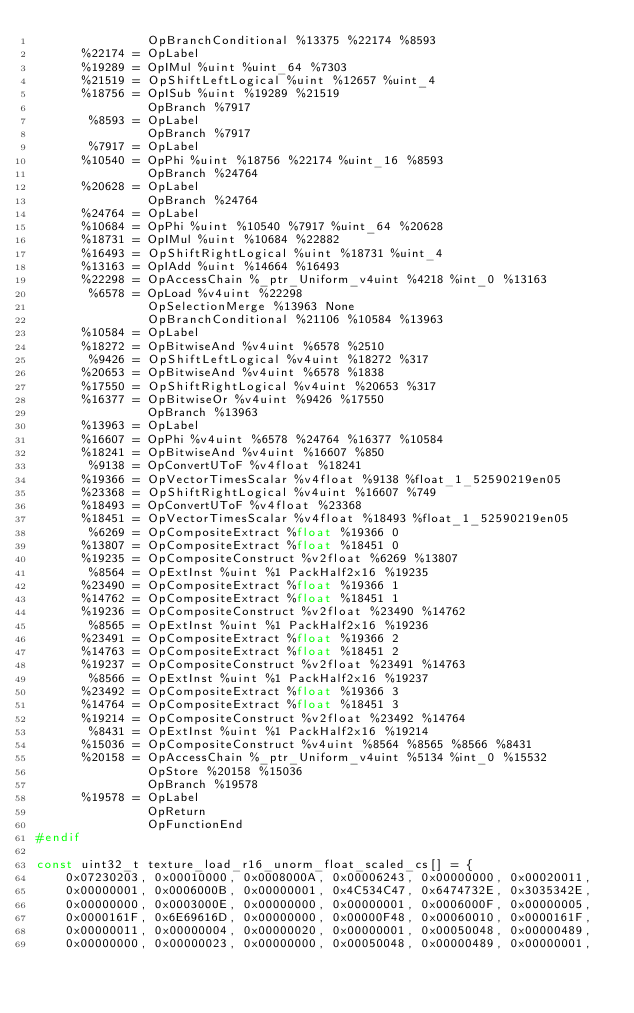Convert code to text. <code><loc_0><loc_0><loc_500><loc_500><_C_>               OpBranchConditional %13375 %22174 %8593
      %22174 = OpLabel
      %19289 = OpIMul %uint %uint_64 %7303
      %21519 = OpShiftLeftLogical %uint %12657 %uint_4
      %18756 = OpISub %uint %19289 %21519
               OpBranch %7917
       %8593 = OpLabel
               OpBranch %7917
       %7917 = OpLabel
      %10540 = OpPhi %uint %18756 %22174 %uint_16 %8593
               OpBranch %24764
      %20628 = OpLabel
               OpBranch %24764
      %24764 = OpLabel
      %10684 = OpPhi %uint %10540 %7917 %uint_64 %20628
      %18731 = OpIMul %uint %10684 %22882
      %16493 = OpShiftRightLogical %uint %18731 %uint_4
      %13163 = OpIAdd %uint %14664 %16493
      %22298 = OpAccessChain %_ptr_Uniform_v4uint %4218 %int_0 %13163
       %6578 = OpLoad %v4uint %22298
               OpSelectionMerge %13963 None
               OpBranchConditional %21106 %10584 %13963
      %10584 = OpLabel
      %18272 = OpBitwiseAnd %v4uint %6578 %2510
       %9426 = OpShiftLeftLogical %v4uint %18272 %317
      %20653 = OpBitwiseAnd %v4uint %6578 %1838
      %17550 = OpShiftRightLogical %v4uint %20653 %317
      %16377 = OpBitwiseOr %v4uint %9426 %17550
               OpBranch %13963
      %13963 = OpLabel
      %16607 = OpPhi %v4uint %6578 %24764 %16377 %10584
      %18241 = OpBitwiseAnd %v4uint %16607 %850
       %9138 = OpConvertUToF %v4float %18241
      %19366 = OpVectorTimesScalar %v4float %9138 %float_1_52590219en05
      %23368 = OpShiftRightLogical %v4uint %16607 %749
      %18493 = OpConvertUToF %v4float %23368
      %18451 = OpVectorTimesScalar %v4float %18493 %float_1_52590219en05
       %6269 = OpCompositeExtract %float %19366 0
      %13807 = OpCompositeExtract %float %18451 0
      %19235 = OpCompositeConstruct %v2float %6269 %13807
       %8564 = OpExtInst %uint %1 PackHalf2x16 %19235
      %23490 = OpCompositeExtract %float %19366 1
      %14762 = OpCompositeExtract %float %18451 1
      %19236 = OpCompositeConstruct %v2float %23490 %14762
       %8565 = OpExtInst %uint %1 PackHalf2x16 %19236
      %23491 = OpCompositeExtract %float %19366 2
      %14763 = OpCompositeExtract %float %18451 2
      %19237 = OpCompositeConstruct %v2float %23491 %14763
       %8566 = OpExtInst %uint %1 PackHalf2x16 %19237
      %23492 = OpCompositeExtract %float %19366 3
      %14764 = OpCompositeExtract %float %18451 3
      %19214 = OpCompositeConstruct %v2float %23492 %14764
       %8431 = OpExtInst %uint %1 PackHalf2x16 %19214
      %15036 = OpCompositeConstruct %v4uint %8564 %8565 %8566 %8431
      %20158 = OpAccessChain %_ptr_Uniform_v4uint %5134 %int_0 %15532
               OpStore %20158 %15036
               OpBranch %19578
      %19578 = OpLabel
               OpReturn
               OpFunctionEnd
#endif

const uint32_t texture_load_r16_unorm_float_scaled_cs[] = {
    0x07230203, 0x00010000, 0x0008000A, 0x00006243, 0x00000000, 0x00020011,
    0x00000001, 0x0006000B, 0x00000001, 0x4C534C47, 0x6474732E, 0x3035342E,
    0x00000000, 0x0003000E, 0x00000000, 0x00000001, 0x0006000F, 0x00000005,
    0x0000161F, 0x6E69616D, 0x00000000, 0x00000F48, 0x00060010, 0x0000161F,
    0x00000011, 0x00000004, 0x00000020, 0x00000001, 0x00050048, 0x00000489,
    0x00000000, 0x00000023, 0x00000000, 0x00050048, 0x00000489, 0x00000001,</code> 